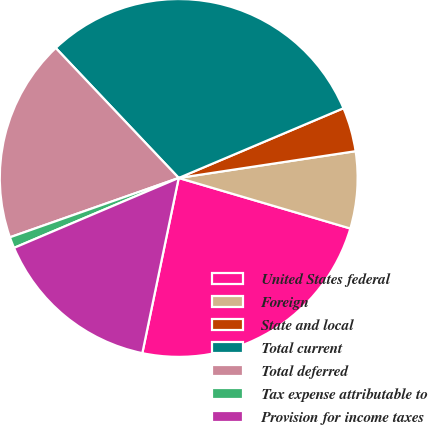Convert chart. <chart><loc_0><loc_0><loc_500><loc_500><pie_chart><fcel>United States federal<fcel>Foreign<fcel>State and local<fcel>Total current<fcel>Total deferred<fcel>Tax expense attributable to<fcel>Provision for income taxes<nl><fcel>23.7%<fcel>6.95%<fcel>3.98%<fcel>30.69%<fcel>18.32%<fcel>1.01%<fcel>15.35%<nl></chart> 